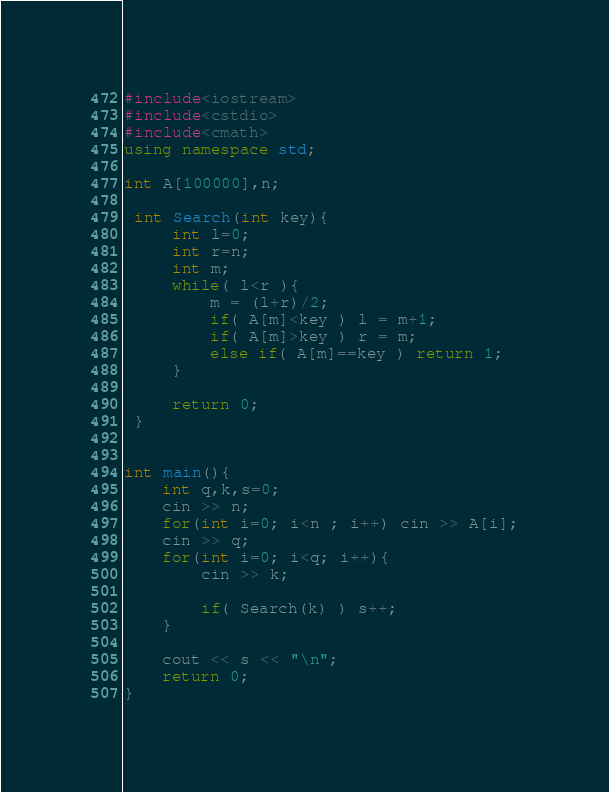<code> <loc_0><loc_0><loc_500><loc_500><_C++_>#include<iostream>
#include<cstdio>
#include<cmath>
using namespace std;

int A[100000],n;

 int Search(int key){
	 int l=0;
	 int r=n;
	 int m;
	 while( l<r ){
		 m = (l+r)/2;
		 if( A[m]<key ) l = m+1;
		 if( A[m]>key ) r = m;
		 else if( A[m]==key ) return 1;
	 }

	 return 0;
 }


int main(){
	int q,k,s=0;
	cin >> n;
	for(int i=0; i<n ; i++) cin >> A[i];
	cin >> q;
	for(int i=0; i<q; i++){
		cin >> k;

		if( Search(k) ) s++;
	}

	cout << s << "\n";
	return 0;
}</code> 